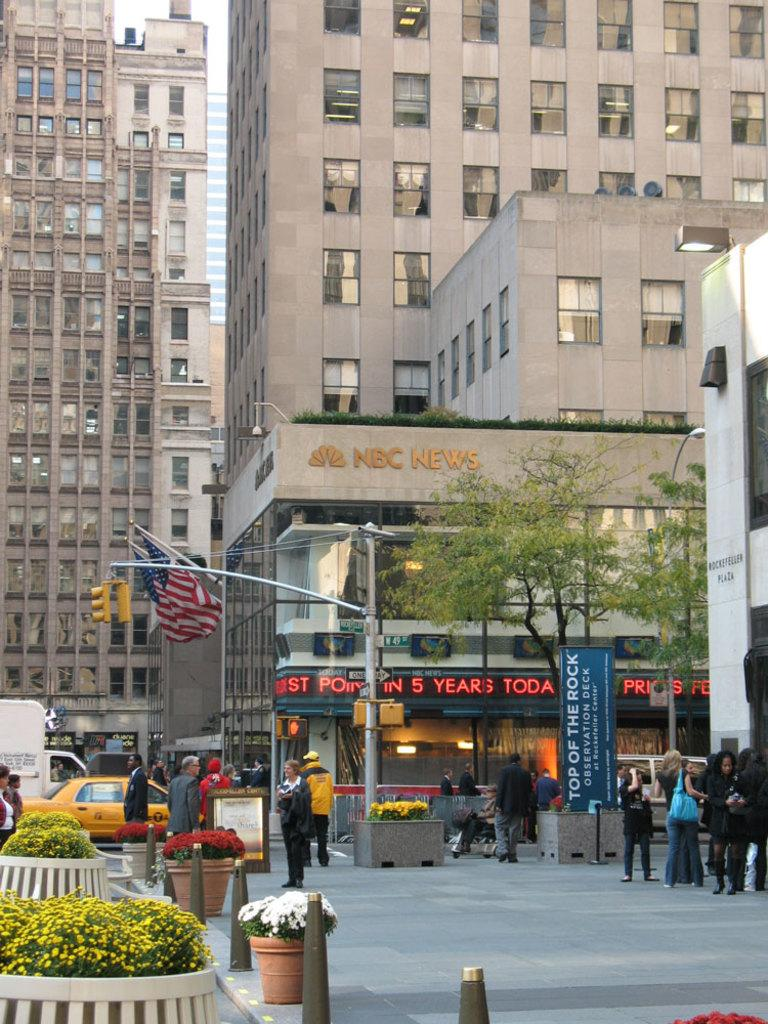<image>
Write a terse but informative summary of the picture. A downtown city scene with the NBC News building in the middle. 